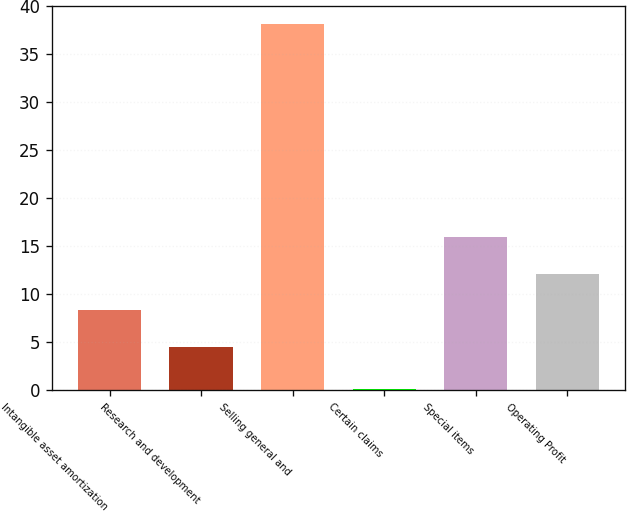Convert chart. <chart><loc_0><loc_0><loc_500><loc_500><bar_chart><fcel>Intangible asset amortization<fcel>Research and development<fcel>Selling general and<fcel>Certain claims<fcel>Special items<fcel>Operating Profit<nl><fcel>8.3<fcel>4.5<fcel>38.1<fcel>0.1<fcel>15.9<fcel>12.1<nl></chart> 